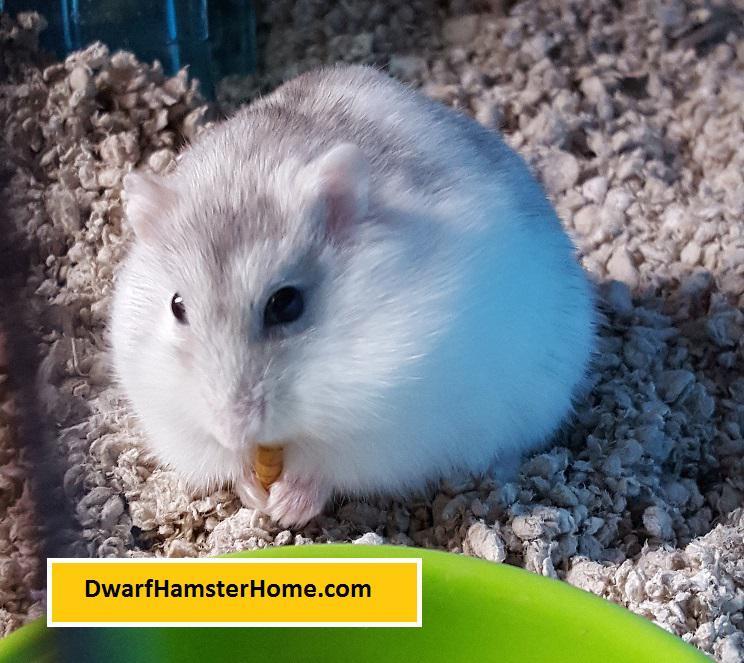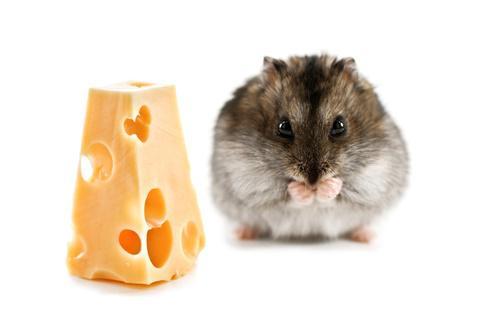The first image is the image on the left, the second image is the image on the right. For the images shown, is this caption "There are no more than 2 hamsters in the image pair" true? Answer yes or no. Yes. 